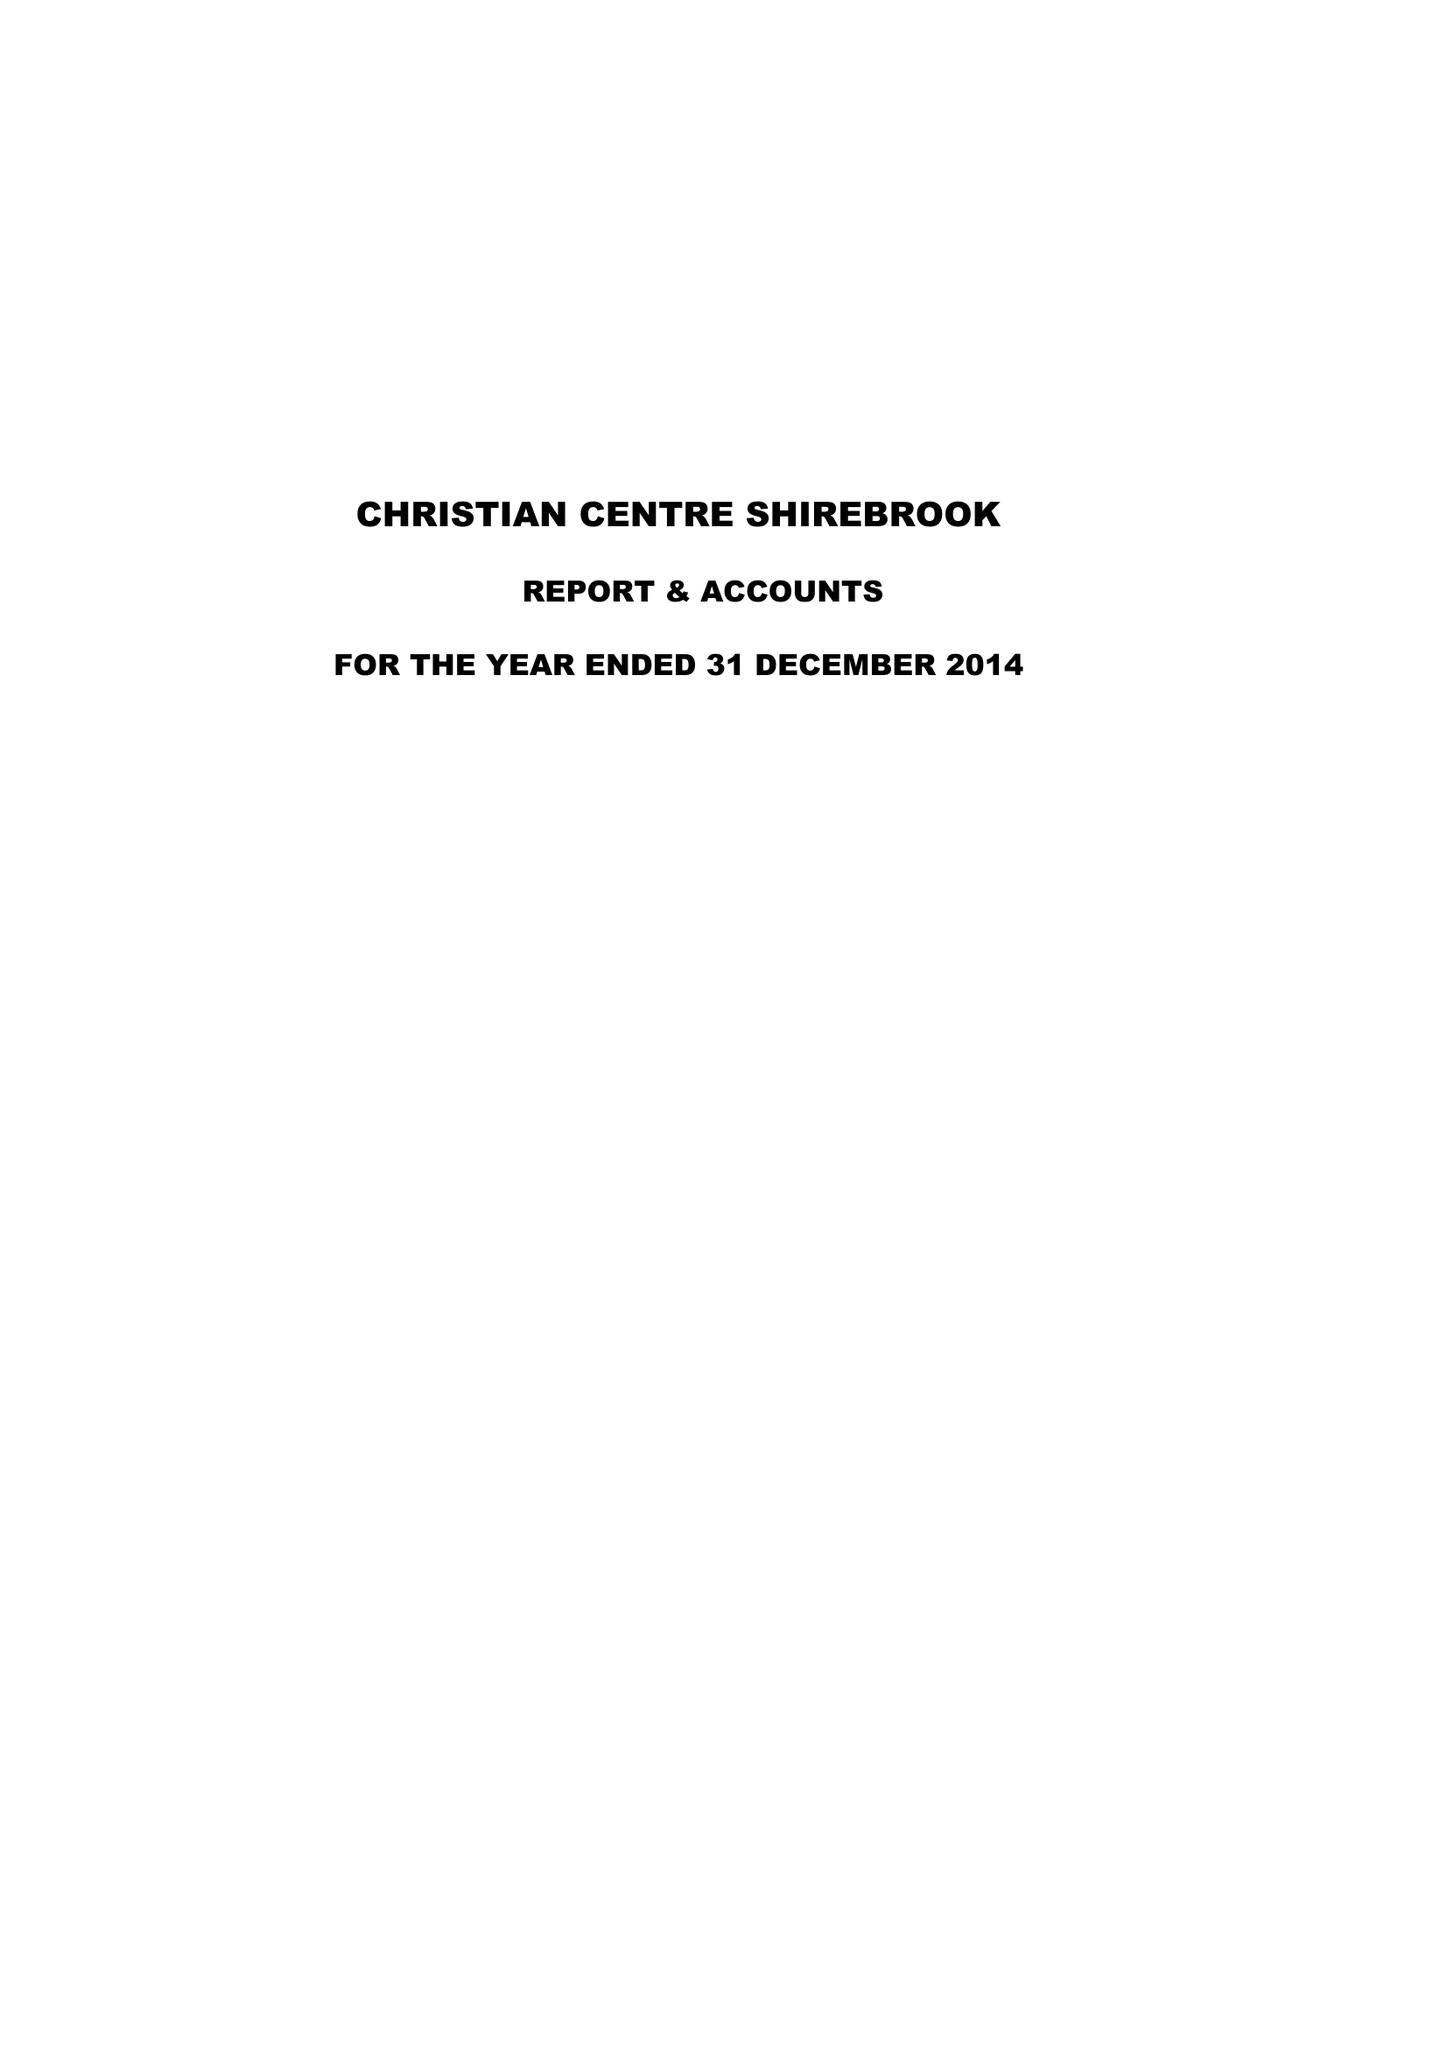What is the value for the address__street_line?
Answer the question using a single word or phrase. None 